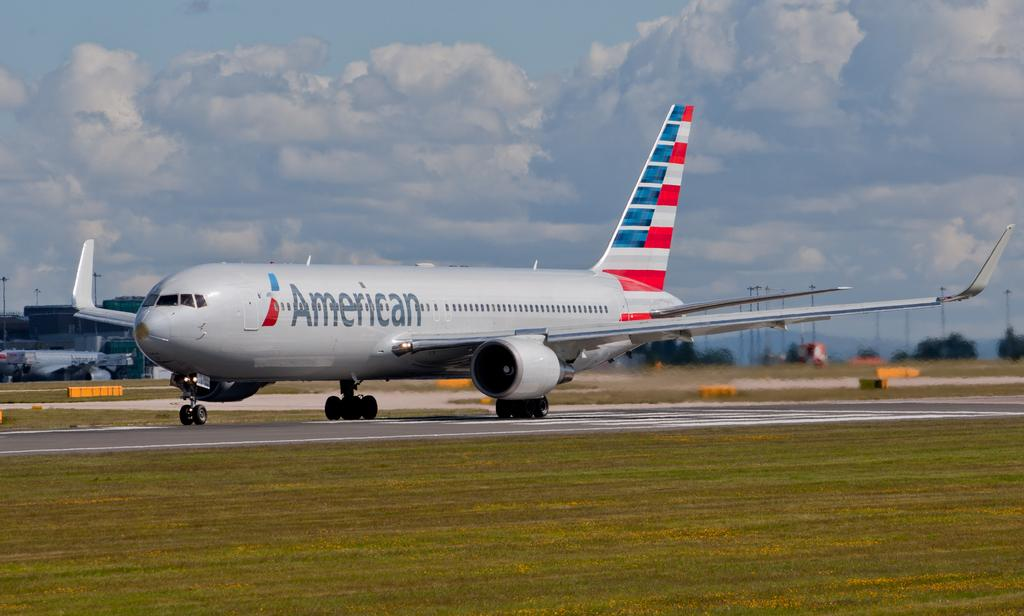<image>
Write a terse but informative summary of the picture. An American airplane that is driving on the runway 